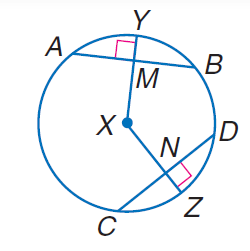Answer the mathemtical geometry problem and directly provide the correct option letter.
Question: In \odot X, A B = 30, C D = 30, and m \widehat C Z = 40. Find C N.
Choices: A: 10 B: 15 C: 20 D: 30 B 